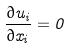Convert formula to latex. <formula><loc_0><loc_0><loc_500><loc_500>\frac { \partial u _ { i } } { \partial x _ { i } } = 0</formula> 